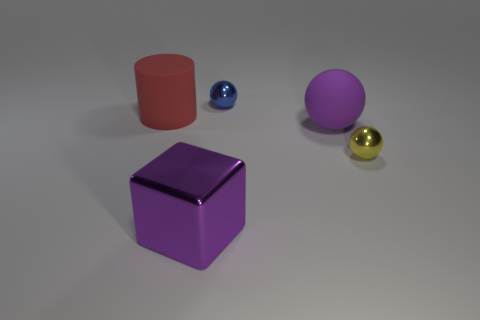What number of big purple balls are right of the big purple thing that is in front of the small ball that is to the right of the big matte ball?
Provide a succinct answer. 1. Is the number of large blocks in front of the large matte sphere less than the number of tiny objects?
Keep it short and to the point. Yes. Are there any other things that have the same shape as the tiny yellow metal object?
Provide a succinct answer. Yes. The rubber thing that is behind the big ball has what shape?
Give a very brief answer. Cylinder. The shiny object to the right of the small ball that is to the left of the metallic sphere in front of the tiny blue shiny sphere is what shape?
Ensure brevity in your answer.  Sphere. How many objects are either large metallic blocks or green matte cubes?
Give a very brief answer. 1. There is a large purple thing to the right of the purple metallic block; is its shape the same as the thing behind the cylinder?
Make the answer very short. Yes. What number of objects are on the left side of the small yellow metal sphere and behind the large cube?
Ensure brevity in your answer.  3. What number of other objects are there of the same size as the blue metal ball?
Your answer should be very brief. 1. There is a big object that is behind the shiny block and in front of the cylinder; what is it made of?
Give a very brief answer. Rubber. 